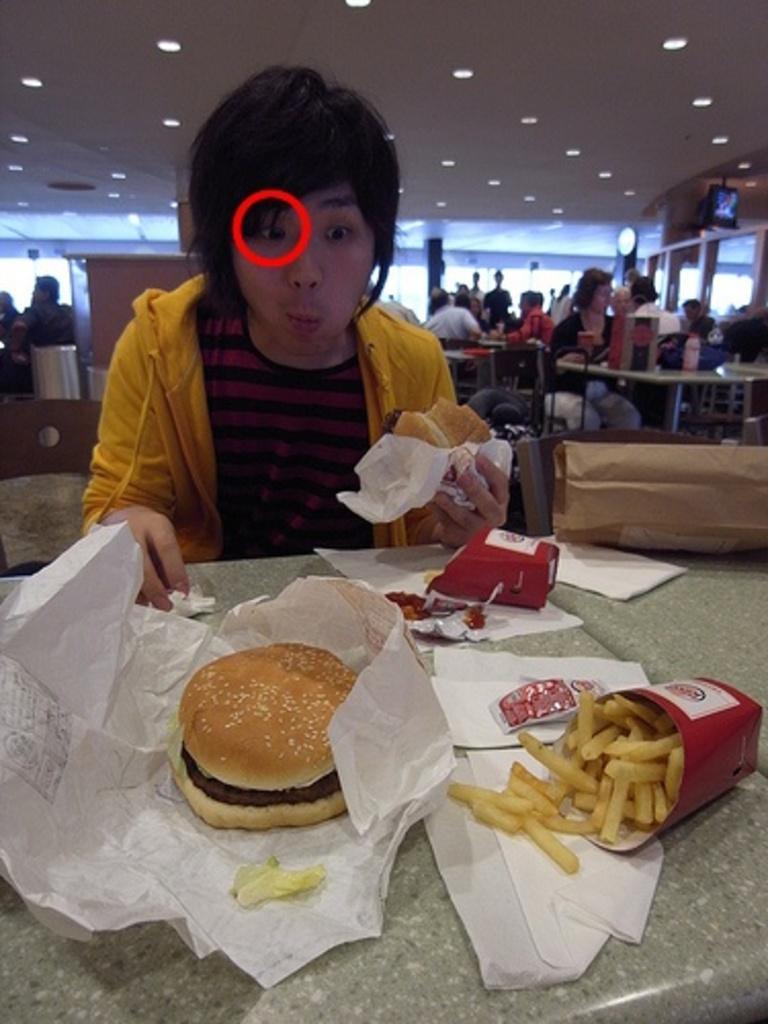In one or two sentences, can you explain what this image depicts? In this image there is a person sat on the chair and he is holding a burger in his hand, in front of him there is a table. On the table there is a burger, french fries, ketchup, tissues and some other objects. In the background there are few people sat on their chairs in front of the table. At the top there is a ceiling with lights and there is a red mark to the person's eye. 